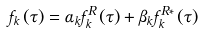Convert formula to latex. <formula><loc_0><loc_0><loc_500><loc_500>f _ { k } \left ( \tau \right ) = \alpha _ { k } f _ { k } ^ { R } \left ( \tau \right ) + \beta _ { k } f _ { k } ^ { R \ast } \left ( \tau \right )</formula> 